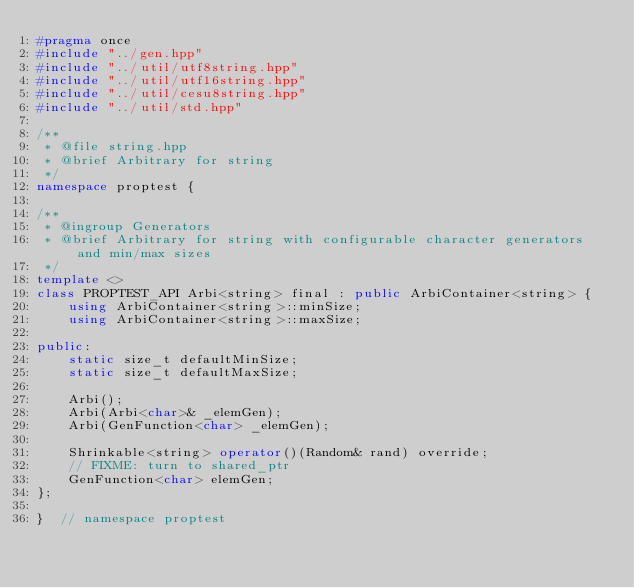Convert code to text. <code><loc_0><loc_0><loc_500><loc_500><_C++_>#pragma once
#include "../gen.hpp"
#include "../util/utf8string.hpp"
#include "../util/utf16string.hpp"
#include "../util/cesu8string.hpp"
#include "../util/std.hpp"

/**
 * @file string.hpp
 * @brief Arbitrary for string
 */
namespace proptest {

/**
 * @ingroup Generators
 * @brief Arbitrary for string with configurable character generators and min/max sizes
 */
template <>
class PROPTEST_API Arbi<string> final : public ArbiContainer<string> {
    using ArbiContainer<string>::minSize;
    using ArbiContainer<string>::maxSize;

public:
    static size_t defaultMinSize;
    static size_t defaultMaxSize;

    Arbi();
    Arbi(Arbi<char>& _elemGen);
    Arbi(GenFunction<char> _elemGen);

    Shrinkable<string> operator()(Random& rand) override;
    // FIXME: turn to shared_ptr
    GenFunction<char> elemGen;
};

}  // namespace proptest
</code> 